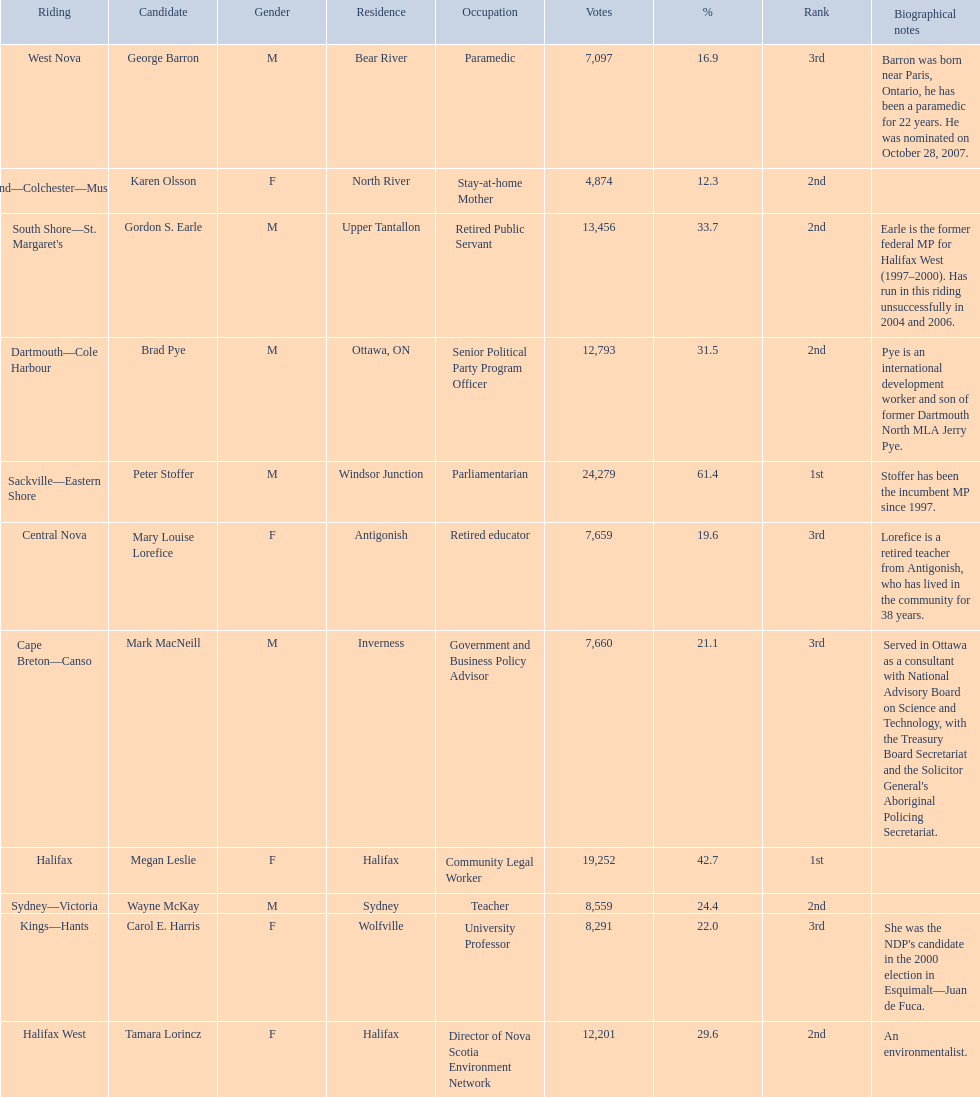Who were all of the new democratic party candidates during the 2008 canadian federal election? Mark MacNeill, Mary Louise Lorefice, Karen Olsson, Brad Pye, Megan Leslie, Tamara Lorincz, Carol E. Harris, Peter Stoffer, Gordon S. Earle, Wayne McKay, George Barron. And between mark macneill and karen olsson, which candidate received more votes? Mark MacNeill. 